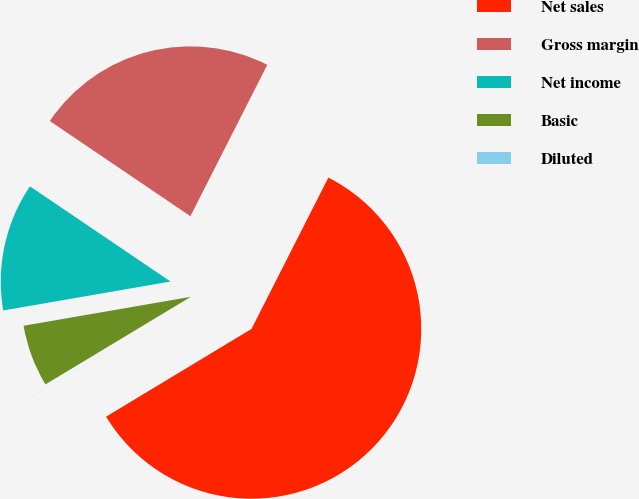Convert chart to OTSL. <chart><loc_0><loc_0><loc_500><loc_500><pie_chart><fcel>Net sales<fcel>Gross margin<fcel>Net income<fcel>Basic<fcel>Diluted<nl><fcel>58.88%<fcel>23.01%<fcel>12.2%<fcel>5.9%<fcel>0.01%<nl></chart> 